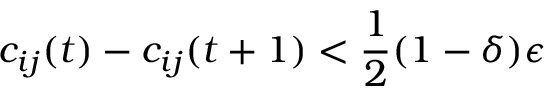Convert formula to latex. <formula><loc_0><loc_0><loc_500><loc_500>c _ { i j } ( t ) - c _ { i j } ( t + 1 ) < \frac { 1 } { 2 } ( 1 - \delta ) \epsilon</formula> 